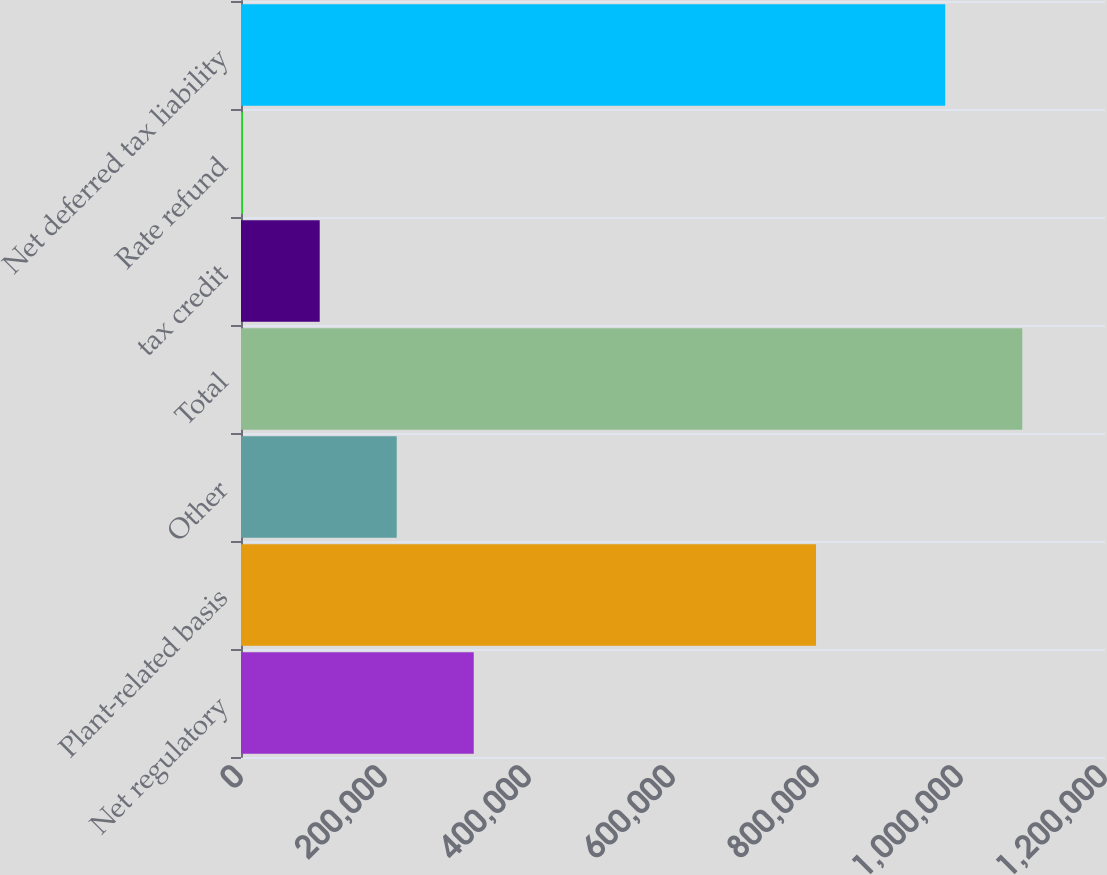<chart> <loc_0><loc_0><loc_500><loc_500><bar_chart><fcel>Net regulatory<fcel>Plant-related basis<fcel>Other<fcel>Total<fcel>tax credit<fcel>Rate refund<fcel>Net deferred tax liability<nl><fcel>323270<fcel>798641<fcel>216297<fcel>1.08507e+06<fcel>109324<fcel>2351<fcel>978093<nl></chart> 